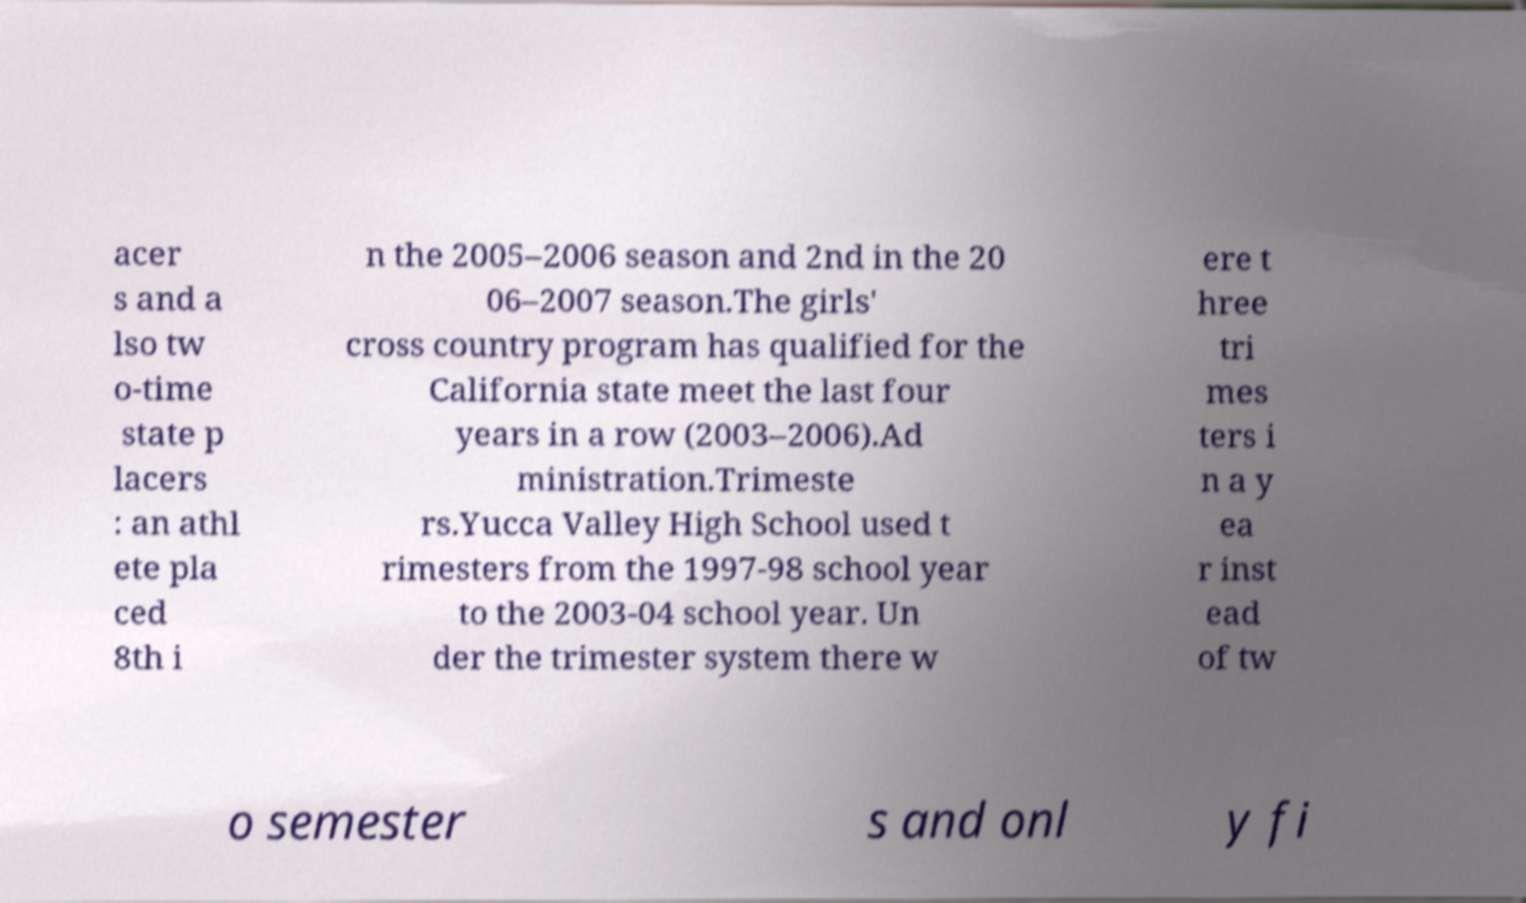Can you read and provide the text displayed in the image?This photo seems to have some interesting text. Can you extract and type it out for me? acer s and a lso tw o-time state p lacers : an athl ete pla ced 8th i n the 2005–2006 season and 2nd in the 20 06–2007 season.The girls' cross country program has qualified for the California state meet the last four years in a row (2003–2006).Ad ministration.Trimeste rs.Yucca Valley High School used t rimesters from the 1997-98 school year to the 2003-04 school year. Un der the trimester system there w ere t hree tri mes ters i n a y ea r inst ead of tw o semester s and onl y fi 